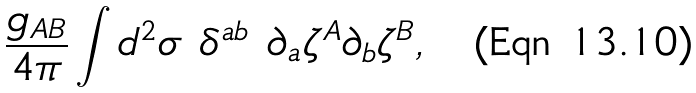Convert formula to latex. <formula><loc_0><loc_0><loc_500><loc_500>\frac { g _ { A B } } { 4 \pi } \int d ^ { 2 } \sigma \ \delta ^ { a b } \ \partial _ { a } \zeta ^ { A } \partial _ { b } \zeta ^ { B } ,</formula> 